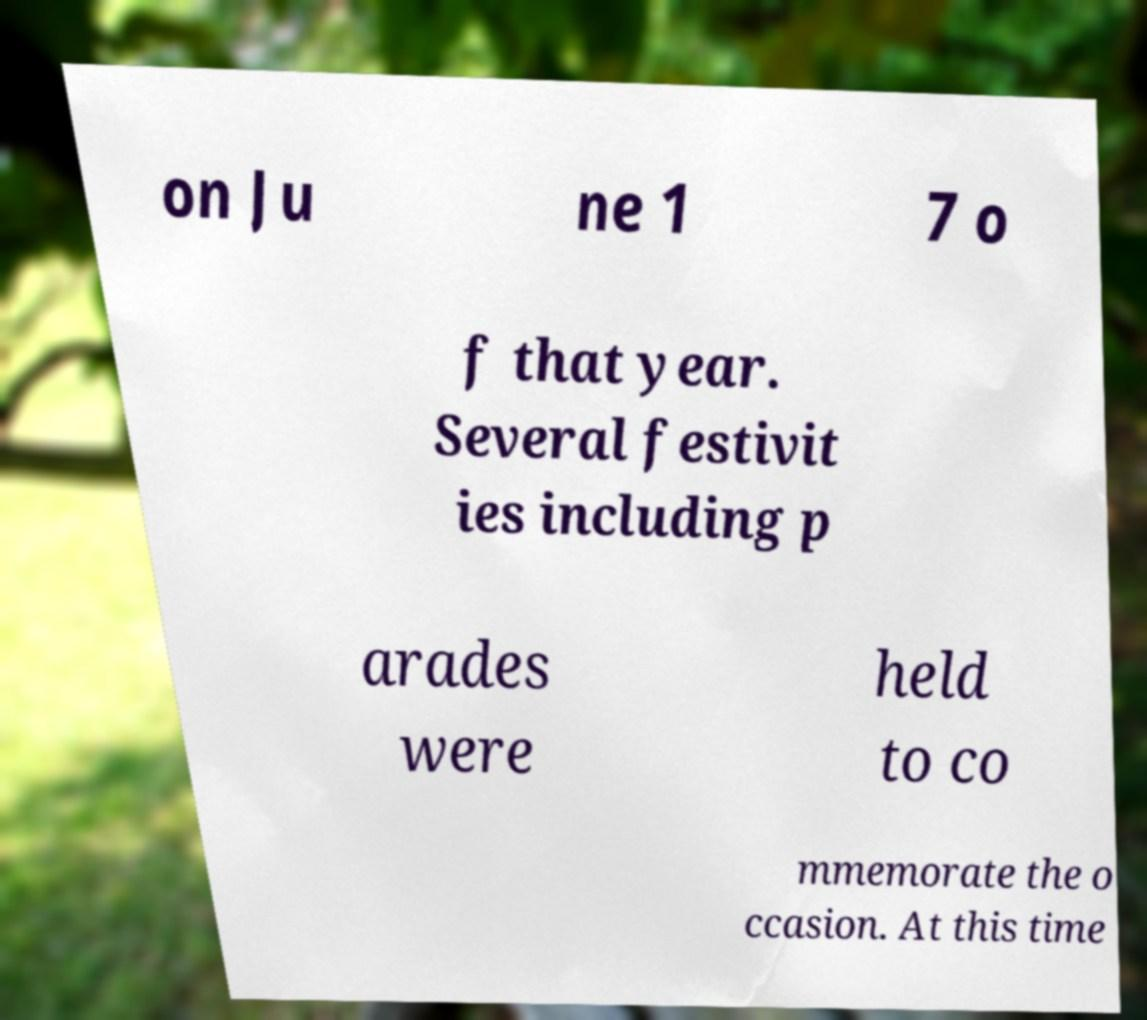There's text embedded in this image that I need extracted. Can you transcribe it verbatim? on Ju ne 1 7 o f that year. Several festivit ies including p arades were held to co mmemorate the o ccasion. At this time 